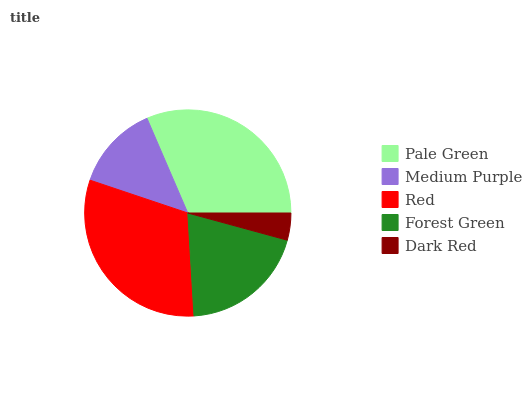Is Dark Red the minimum?
Answer yes or no. Yes. Is Pale Green the maximum?
Answer yes or no. Yes. Is Medium Purple the minimum?
Answer yes or no. No. Is Medium Purple the maximum?
Answer yes or no. No. Is Pale Green greater than Medium Purple?
Answer yes or no. Yes. Is Medium Purple less than Pale Green?
Answer yes or no. Yes. Is Medium Purple greater than Pale Green?
Answer yes or no. No. Is Pale Green less than Medium Purple?
Answer yes or no. No. Is Forest Green the high median?
Answer yes or no. Yes. Is Forest Green the low median?
Answer yes or no. Yes. Is Dark Red the high median?
Answer yes or no. No. Is Pale Green the low median?
Answer yes or no. No. 